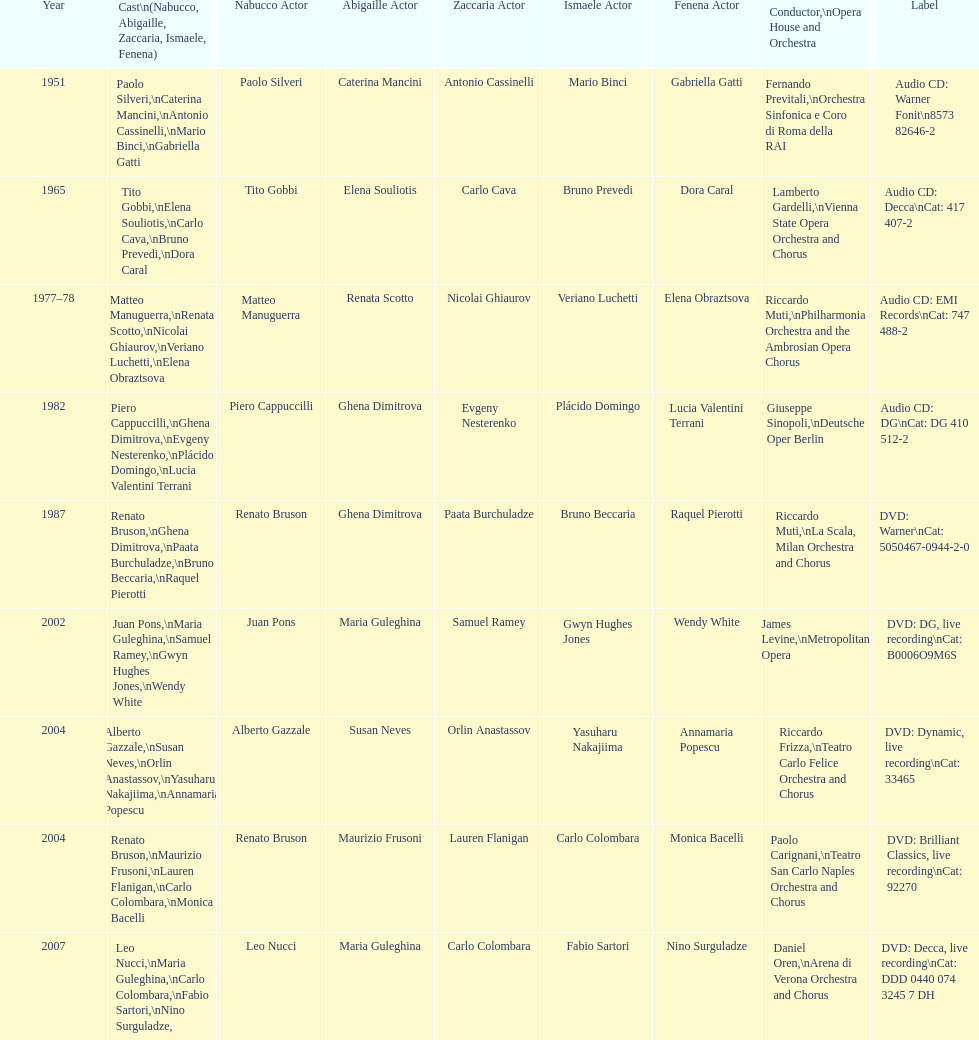When was the recording of nabucco made in the metropolitan opera? 2002. 